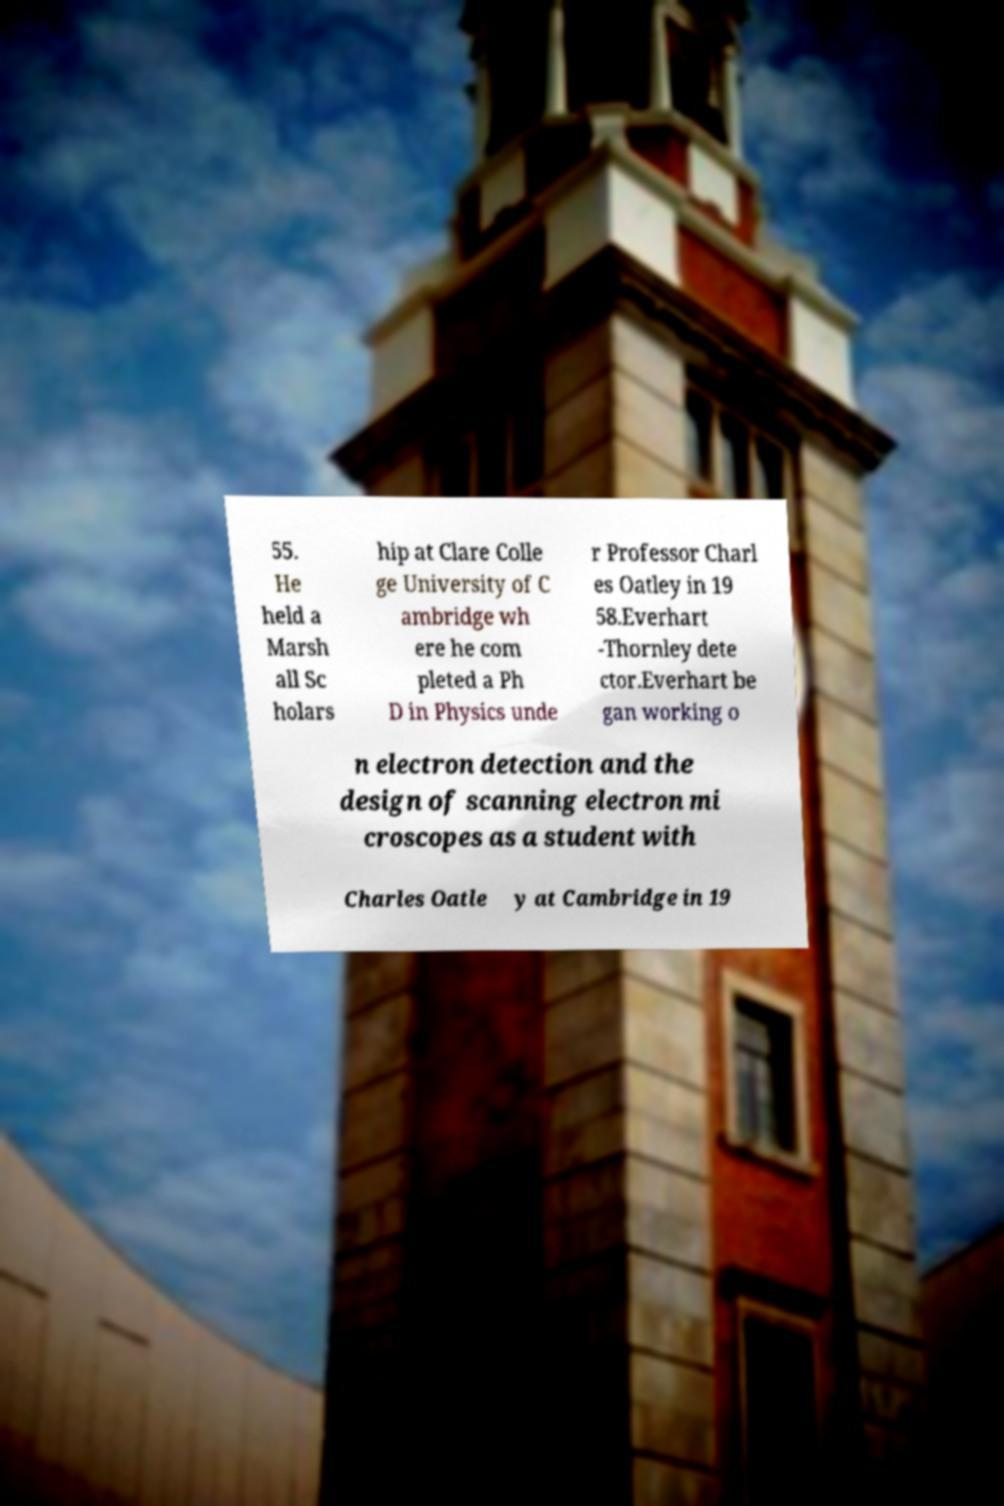Please read and relay the text visible in this image. What does it say? 55. He held a Marsh all Sc holars hip at Clare Colle ge University of C ambridge wh ere he com pleted a Ph D in Physics unde r Professor Charl es Oatley in 19 58.Everhart -Thornley dete ctor.Everhart be gan working o n electron detection and the design of scanning electron mi croscopes as a student with Charles Oatle y at Cambridge in 19 